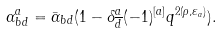Convert formula to latex. <formula><loc_0><loc_0><loc_500><loc_500>\alpha ^ { a } _ { b d } = \bar { \alpha } _ { b d } ( 1 - \delta ^ { a } _ { \overline { d } } ( - 1 ) ^ { [ a ] } q ^ { 2 ( \rho , \varepsilon _ { a } ) } ) .</formula> 